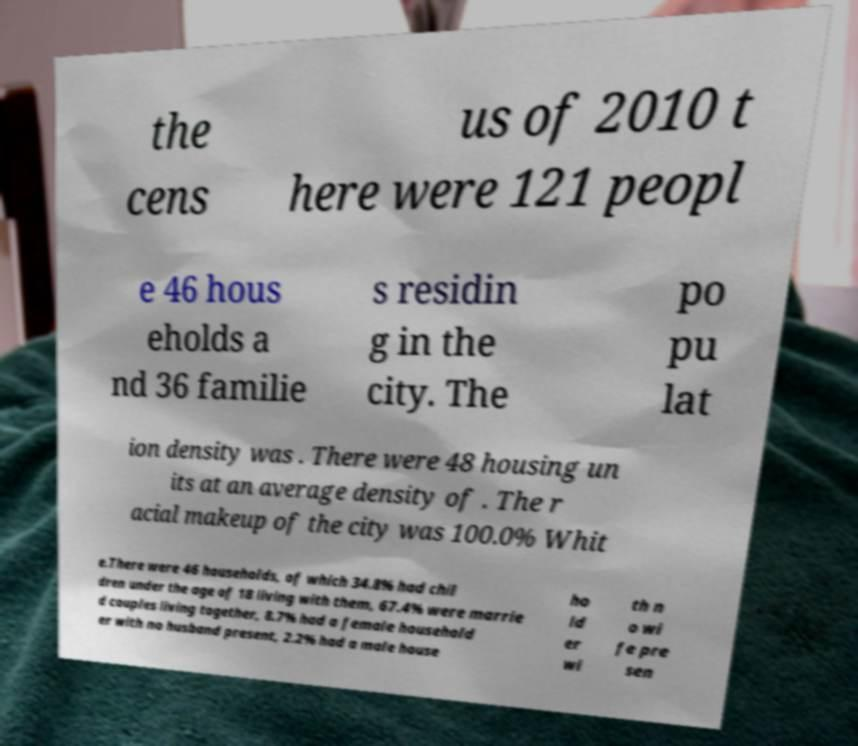Can you read and provide the text displayed in the image?This photo seems to have some interesting text. Can you extract and type it out for me? the cens us of 2010 t here were 121 peopl e 46 hous eholds a nd 36 familie s residin g in the city. The po pu lat ion density was . There were 48 housing un its at an average density of . The r acial makeup of the city was 100.0% Whit e.There were 46 households, of which 34.8% had chil dren under the age of 18 living with them, 67.4% were marrie d couples living together, 8.7% had a female household er with no husband present, 2.2% had a male house ho ld er wi th n o wi fe pre sen 